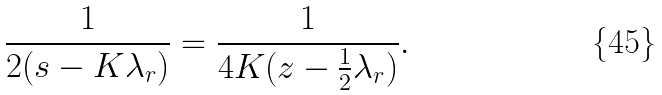<formula> <loc_0><loc_0><loc_500><loc_500>\frac { 1 } { 2 ( s - K \lambda _ { r } ) } = \frac { 1 } { 4 K ( z - \frac { 1 } { 2 } \lambda _ { r } ) } .</formula> 